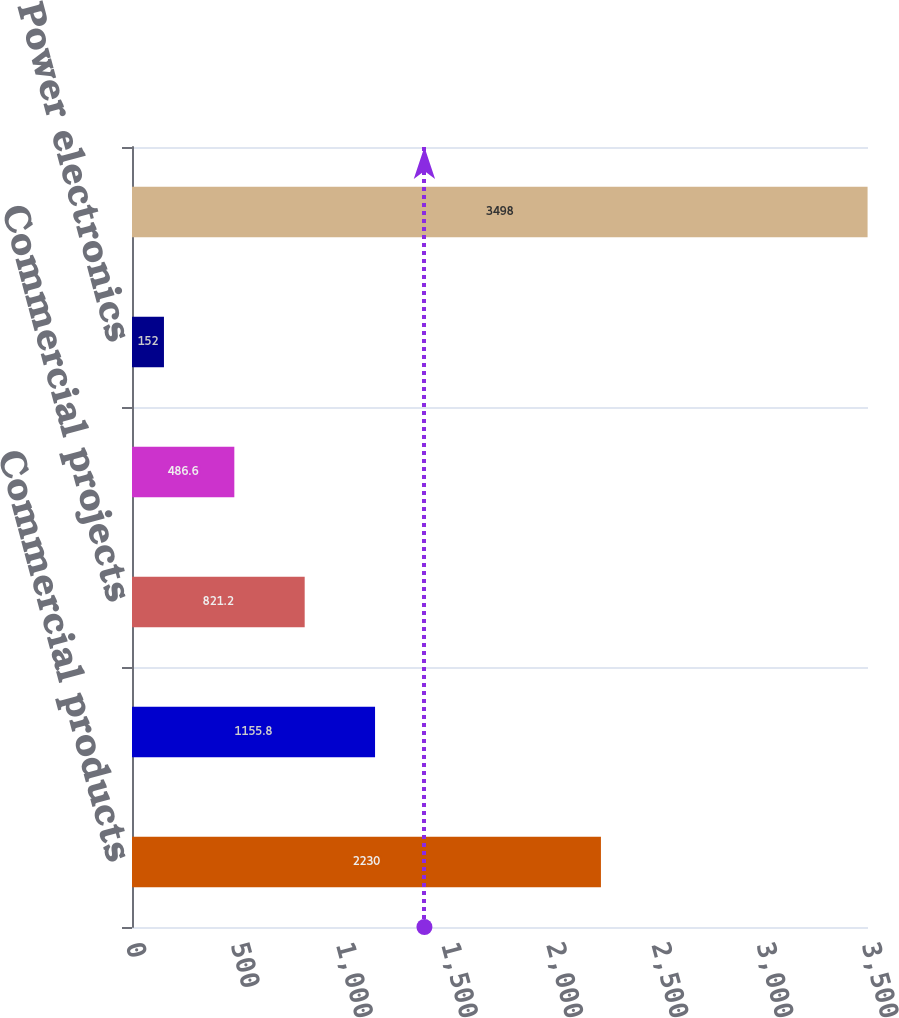<chart> <loc_0><loc_0><loc_500><loc_500><bar_chart><fcel>Commercial products<fcel>Generator technologies<fcel>Commercial projects<fcel>Consumer<fcel>Power electronics<fcel>Total sales<nl><fcel>2230<fcel>1155.8<fcel>821.2<fcel>486.6<fcel>152<fcel>3498<nl></chart> 